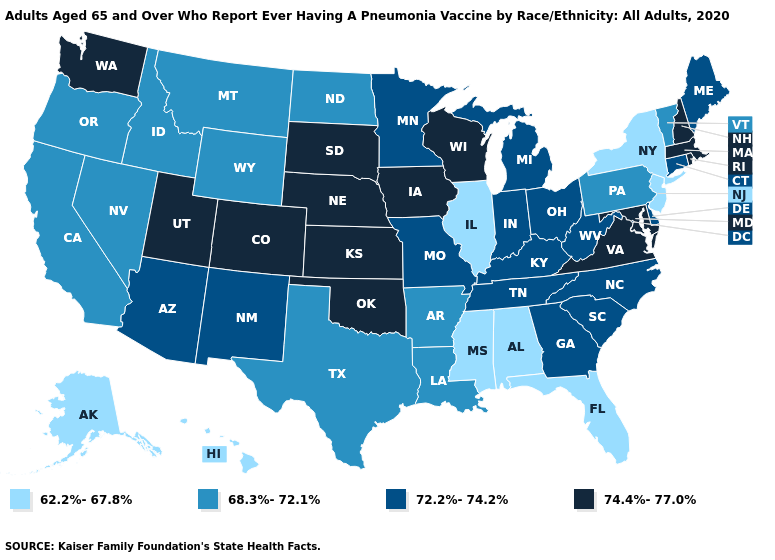What is the lowest value in the MidWest?
Give a very brief answer. 62.2%-67.8%. What is the value of Illinois?
Keep it brief. 62.2%-67.8%. Among the states that border Idaho , which have the lowest value?
Be succinct. Montana, Nevada, Oregon, Wyoming. Does New Mexico have the same value as Kentucky?
Be succinct. Yes. What is the value of South Carolina?
Quick response, please. 72.2%-74.2%. Does the map have missing data?
Concise answer only. No. Name the states that have a value in the range 72.2%-74.2%?
Be succinct. Arizona, Connecticut, Delaware, Georgia, Indiana, Kentucky, Maine, Michigan, Minnesota, Missouri, New Mexico, North Carolina, Ohio, South Carolina, Tennessee, West Virginia. Name the states that have a value in the range 68.3%-72.1%?
Give a very brief answer. Arkansas, California, Idaho, Louisiana, Montana, Nevada, North Dakota, Oregon, Pennsylvania, Texas, Vermont, Wyoming. What is the highest value in the USA?
Answer briefly. 74.4%-77.0%. What is the lowest value in states that border Montana?
Give a very brief answer. 68.3%-72.1%. Which states have the lowest value in the South?
Keep it brief. Alabama, Florida, Mississippi. What is the highest value in the USA?
Keep it brief. 74.4%-77.0%. What is the value of Iowa?
Write a very short answer. 74.4%-77.0%. Does the first symbol in the legend represent the smallest category?
Be succinct. Yes. 